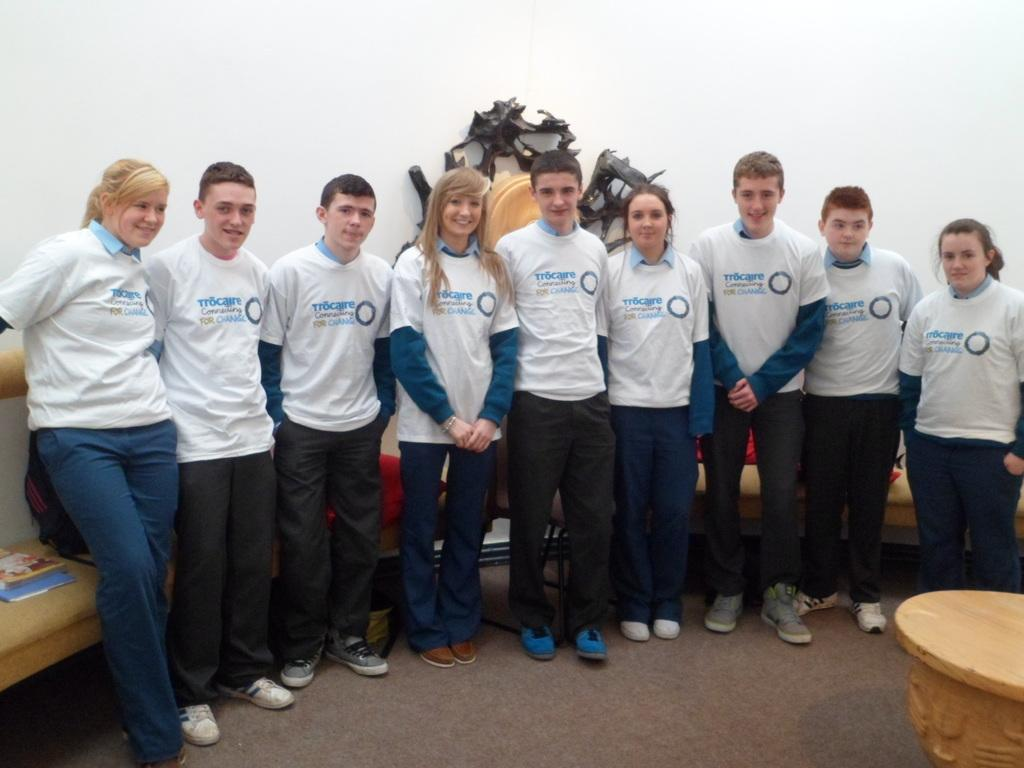How many people are in the image? There is a group of people in the image. What are the people doing in the image? The people are standing. What can be seen in the background of the image? There is a couch in the background of the image. What color is the wall in the image? The wall is white in color. What type of reaction can be seen from the rat in the image? There is no rat present in the image, so it is not possible to determine any reaction from a rat. 